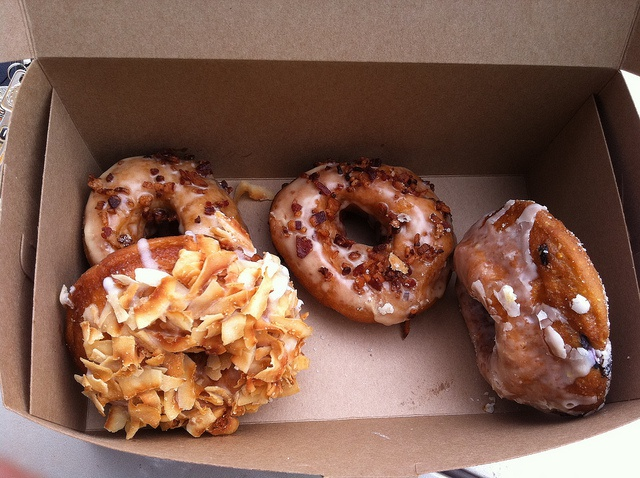Describe the objects in this image and their specific colors. I can see donut in darkgray, tan, brown, and ivory tones, donut in darkgray, maroon, brown, and black tones, donut in darkgray, maroon, brown, and black tones, and donut in darkgray, maroon, brown, and tan tones in this image. 